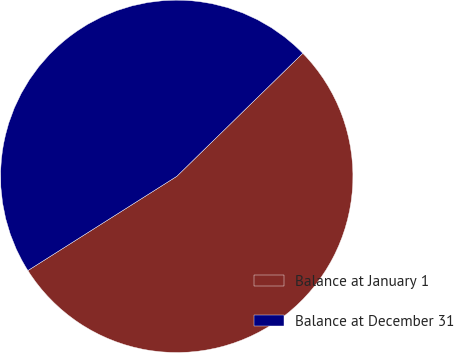Convert chart. <chart><loc_0><loc_0><loc_500><loc_500><pie_chart><fcel>Balance at January 1<fcel>Balance at December 31<nl><fcel>53.33%<fcel>46.67%<nl></chart> 